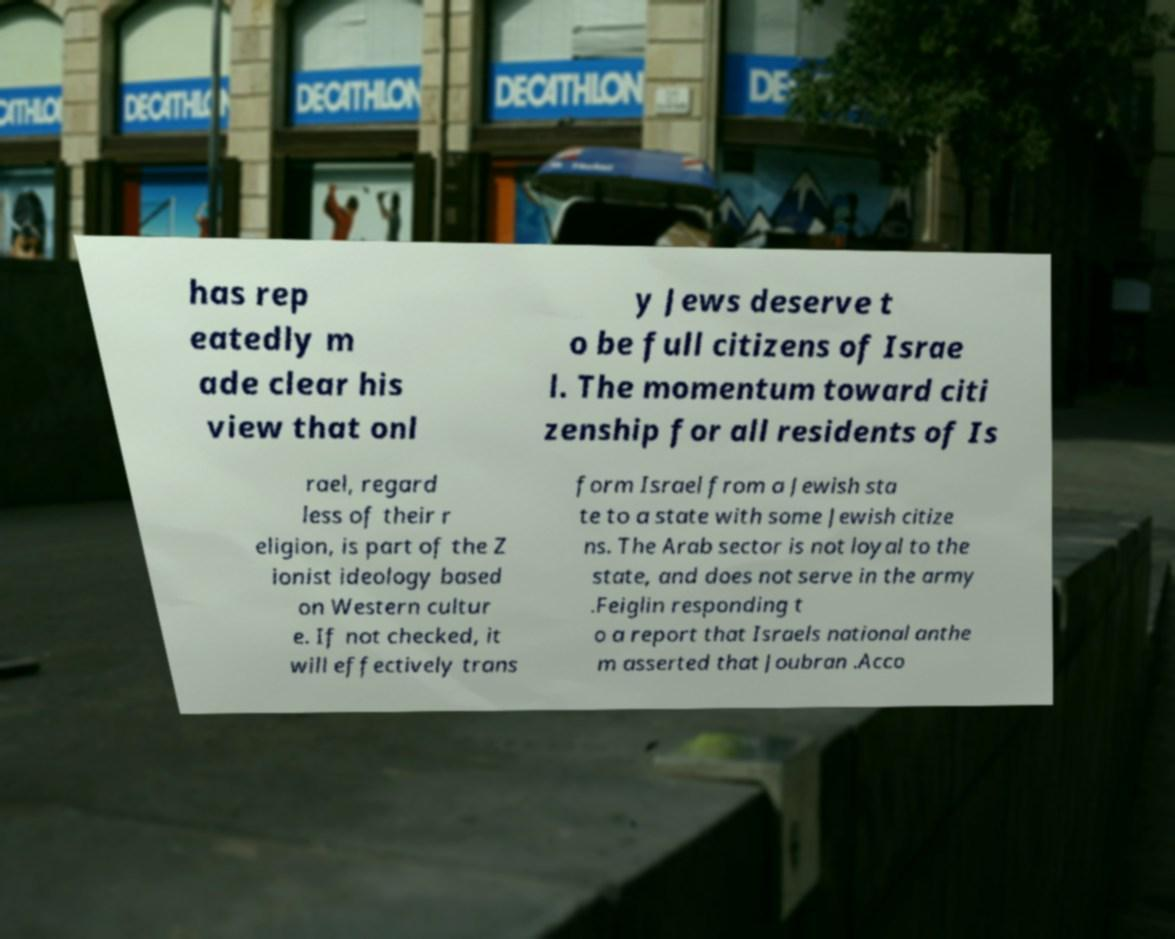Can you accurately transcribe the text from the provided image for me? has rep eatedly m ade clear his view that onl y Jews deserve t o be full citizens of Israe l. The momentum toward citi zenship for all residents of Is rael, regard less of their r eligion, is part of the Z ionist ideology based on Western cultur e. If not checked, it will effectively trans form Israel from a Jewish sta te to a state with some Jewish citize ns. The Arab sector is not loyal to the state, and does not serve in the army .Feiglin responding t o a report that Israels national anthe m asserted that Joubran .Acco 